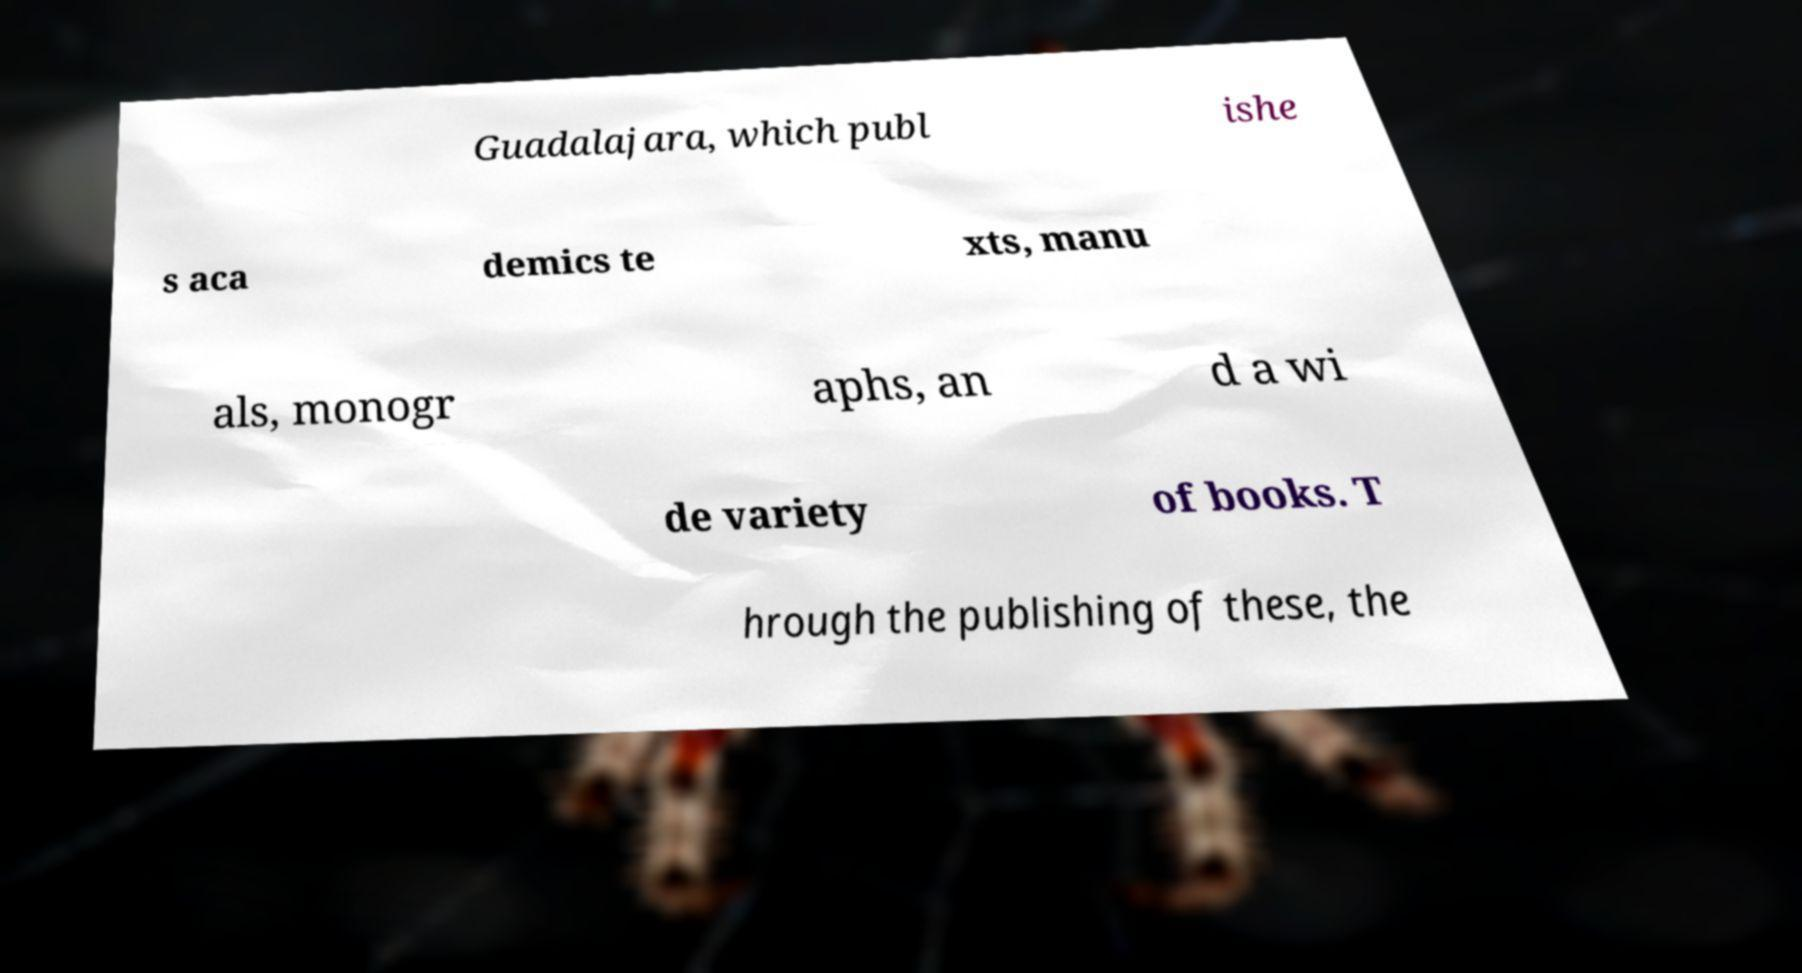Can you accurately transcribe the text from the provided image for me? Guadalajara, which publ ishe s aca demics te xts, manu als, monogr aphs, an d a wi de variety of books. T hrough the publishing of these, the 